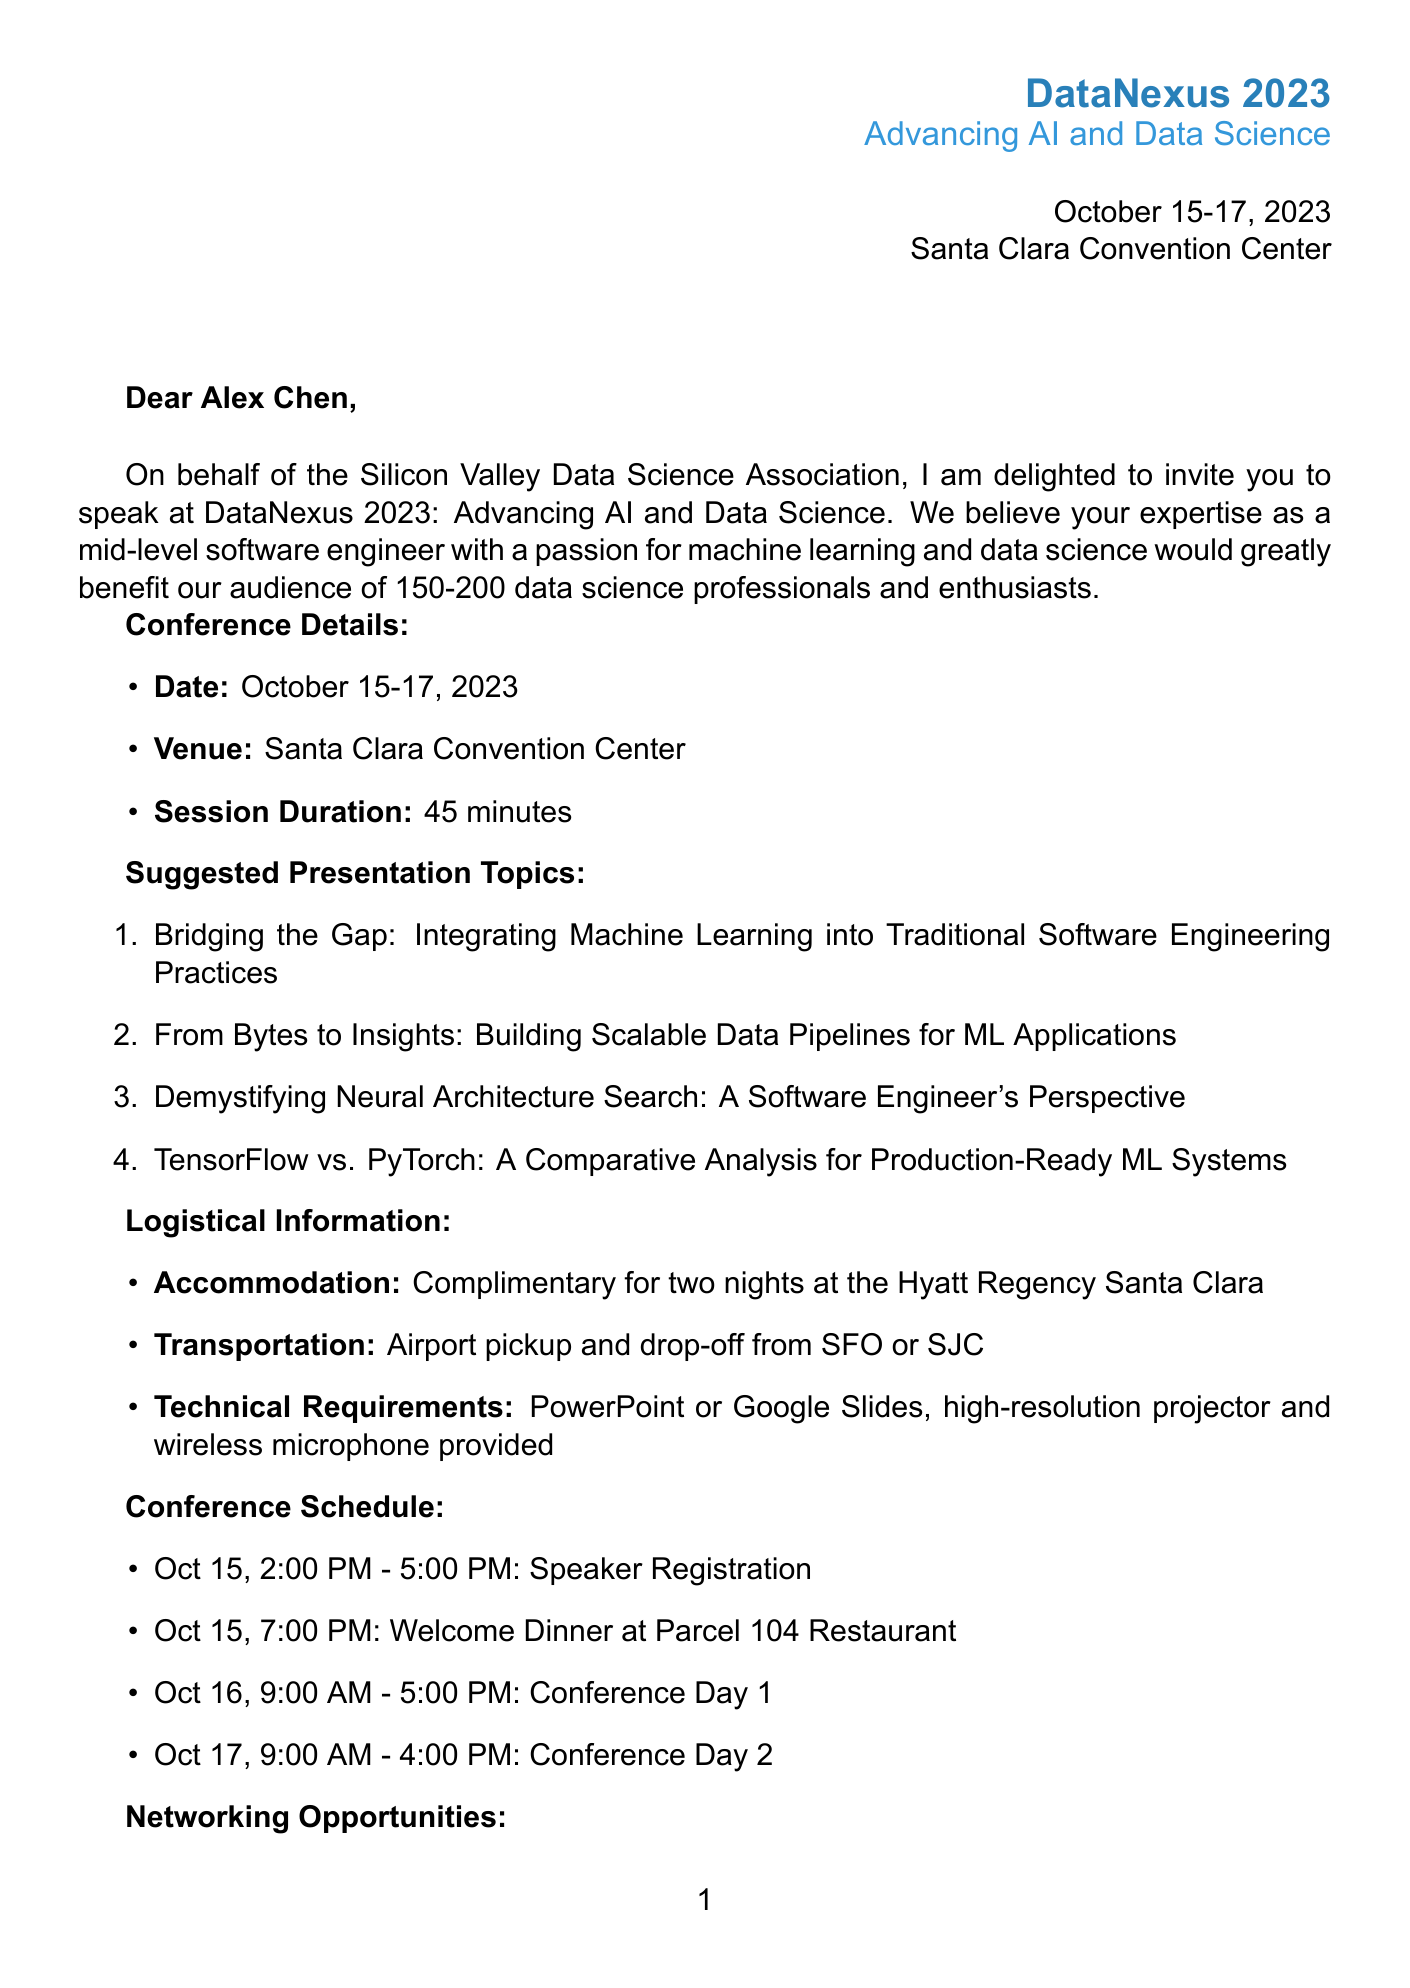What is the event name? The event name is specified in the document as it serves as the title of the invitation.
Answer: DataNexus 2023: Advancing AI and Data Science Who is organizing the conference? The organizer information is stated in the opening section of the letter, indicating who is responsible for the event.
Answer: Silicon Valley Data Science Association What is the session duration? The document explicitly states the duration of the speaker's session, which is important for scheduling.
Answer: 45 minutes What are the suggested presentation topics? The document lists several presentation topics, demonstrating the themes that speakers can choose from.
Answer: Bridging the Gap: Integrating Machine Learning into Traditional Software Engineering Practices, From Bytes to Insights: Building Scalable Data Pipelines for ML Applications, Demystifying Neural Architecture Search: A Software Engineer's Perspective, TensorFlow vs. PyTorch: A Comparative Analysis for Production-Ready ML Systems What is the travel arrangement for the speakers? The document mentions a specific benefit regarding accommodation for speakers, which is critical logistical information.
Answer: Complimentary hotel accommodation for two nights at the Hyatt Regency Santa Clara Which key speaker is founder of DeepLearning.AI? The document includes a list of keynote speakers, with one specifically being noted for their organizational role in a well-known AI initiative.
Answer: Dr. Andrew Ng What is the deadline for submission of required materials? The deadline for submission reflects the time constraints on the speakers and is clearly indicated in the document.
Answer: August 31, 2023 What type of presentation formats are required? The technical requirements section specifies what formats are acceptable for the presentations, which is necessary for preparation.
Answer: PowerPoint or Google Slides What is one networking opportunity mentioned in the document? The document highlights several networking opportunities available at the conference, illustrating options for attendees to engage.
Answer: AI Startup Showcase 